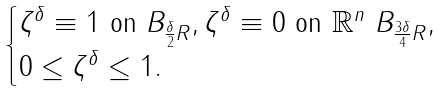<formula> <loc_0><loc_0><loc_500><loc_500>\begin{cases} \zeta ^ { \delta } \equiv 1 \ \text {on} \ B _ { \frac { \delta } { 2 } R } , \zeta ^ { \delta } \equiv 0 \ \text {on} \ \mathbb { R } ^ { n } \ B _ { \frac { 3 \delta } { 4 } R } , \\ 0 \leq \zeta ^ { \delta } \leq 1 . \end{cases}</formula> 